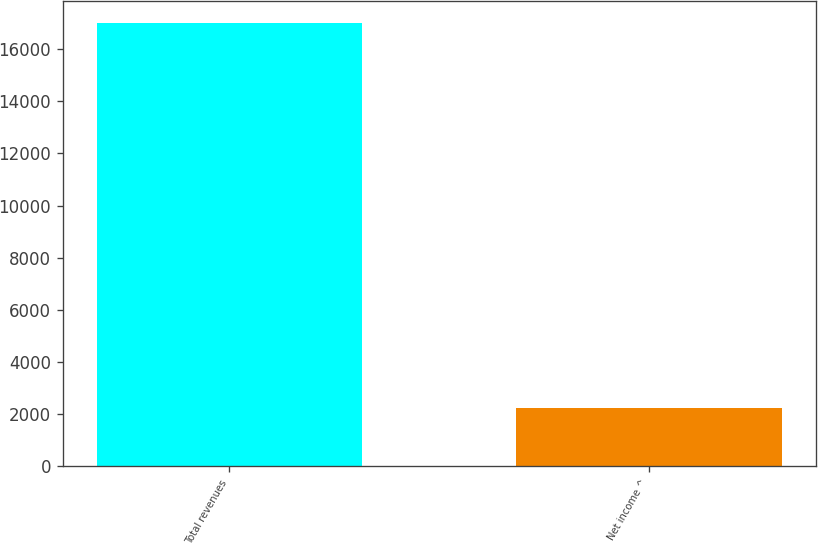Convert chart to OTSL. <chart><loc_0><loc_0><loc_500><loc_500><bar_chart><fcel>Total revenues<fcel>Net income ^<nl><fcel>17008<fcel>2231<nl></chart> 